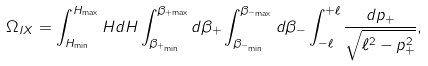Convert formula to latex. <formula><loc_0><loc_0><loc_500><loc_500>\Omega _ { I X } = \int _ { H _ { \min } } ^ { H _ { \max } } H d H \int _ { \beta _ { + _ { \min } } } ^ { \beta _ { + { \max } } } d \beta _ { + } \int _ { \beta _ { - _ { \min } } } ^ { \beta _ { - _ { \max } } } d \beta _ { - } \int _ { - \ell } ^ { + \ell } \frac { d p _ { + } } { \sqrt { \ell ^ { 2 } - p _ { + } ^ { 2 } } } ,</formula> 